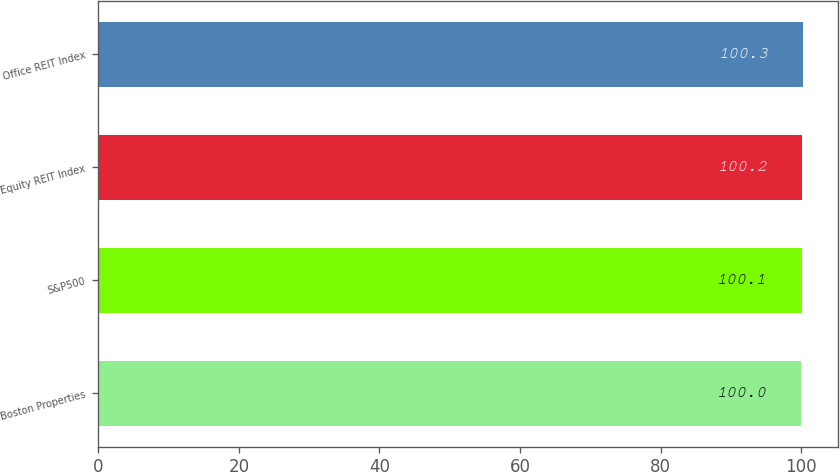Convert chart. <chart><loc_0><loc_0><loc_500><loc_500><bar_chart><fcel>Boston Properties<fcel>S&P500<fcel>Equity REIT Index<fcel>Office REIT Index<nl><fcel>100<fcel>100.1<fcel>100.2<fcel>100.3<nl></chart> 